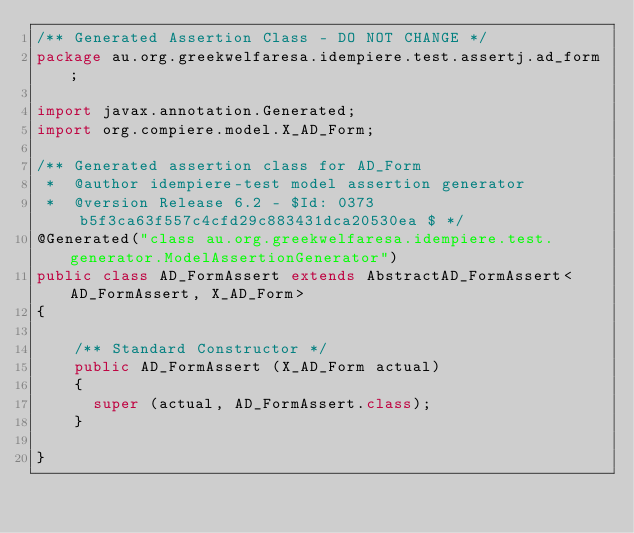<code> <loc_0><loc_0><loc_500><loc_500><_Java_>/** Generated Assertion Class - DO NOT CHANGE */
package au.org.greekwelfaresa.idempiere.test.assertj.ad_form;

import javax.annotation.Generated;
import org.compiere.model.X_AD_Form;

/** Generated assertion class for AD_Form
 *  @author idempiere-test model assertion generator
 *  @version Release 6.2 - $Id: 0373b5f3ca63f557c4cfd29c883431dca20530ea $ */
@Generated("class au.org.greekwelfaresa.idempiere.test.generator.ModelAssertionGenerator")
public class AD_FormAssert extends AbstractAD_FormAssert<AD_FormAssert, X_AD_Form>
{

    /** Standard Constructor */
    public AD_FormAssert (X_AD_Form actual)
    {
      super (actual, AD_FormAssert.class);
    }

}</code> 